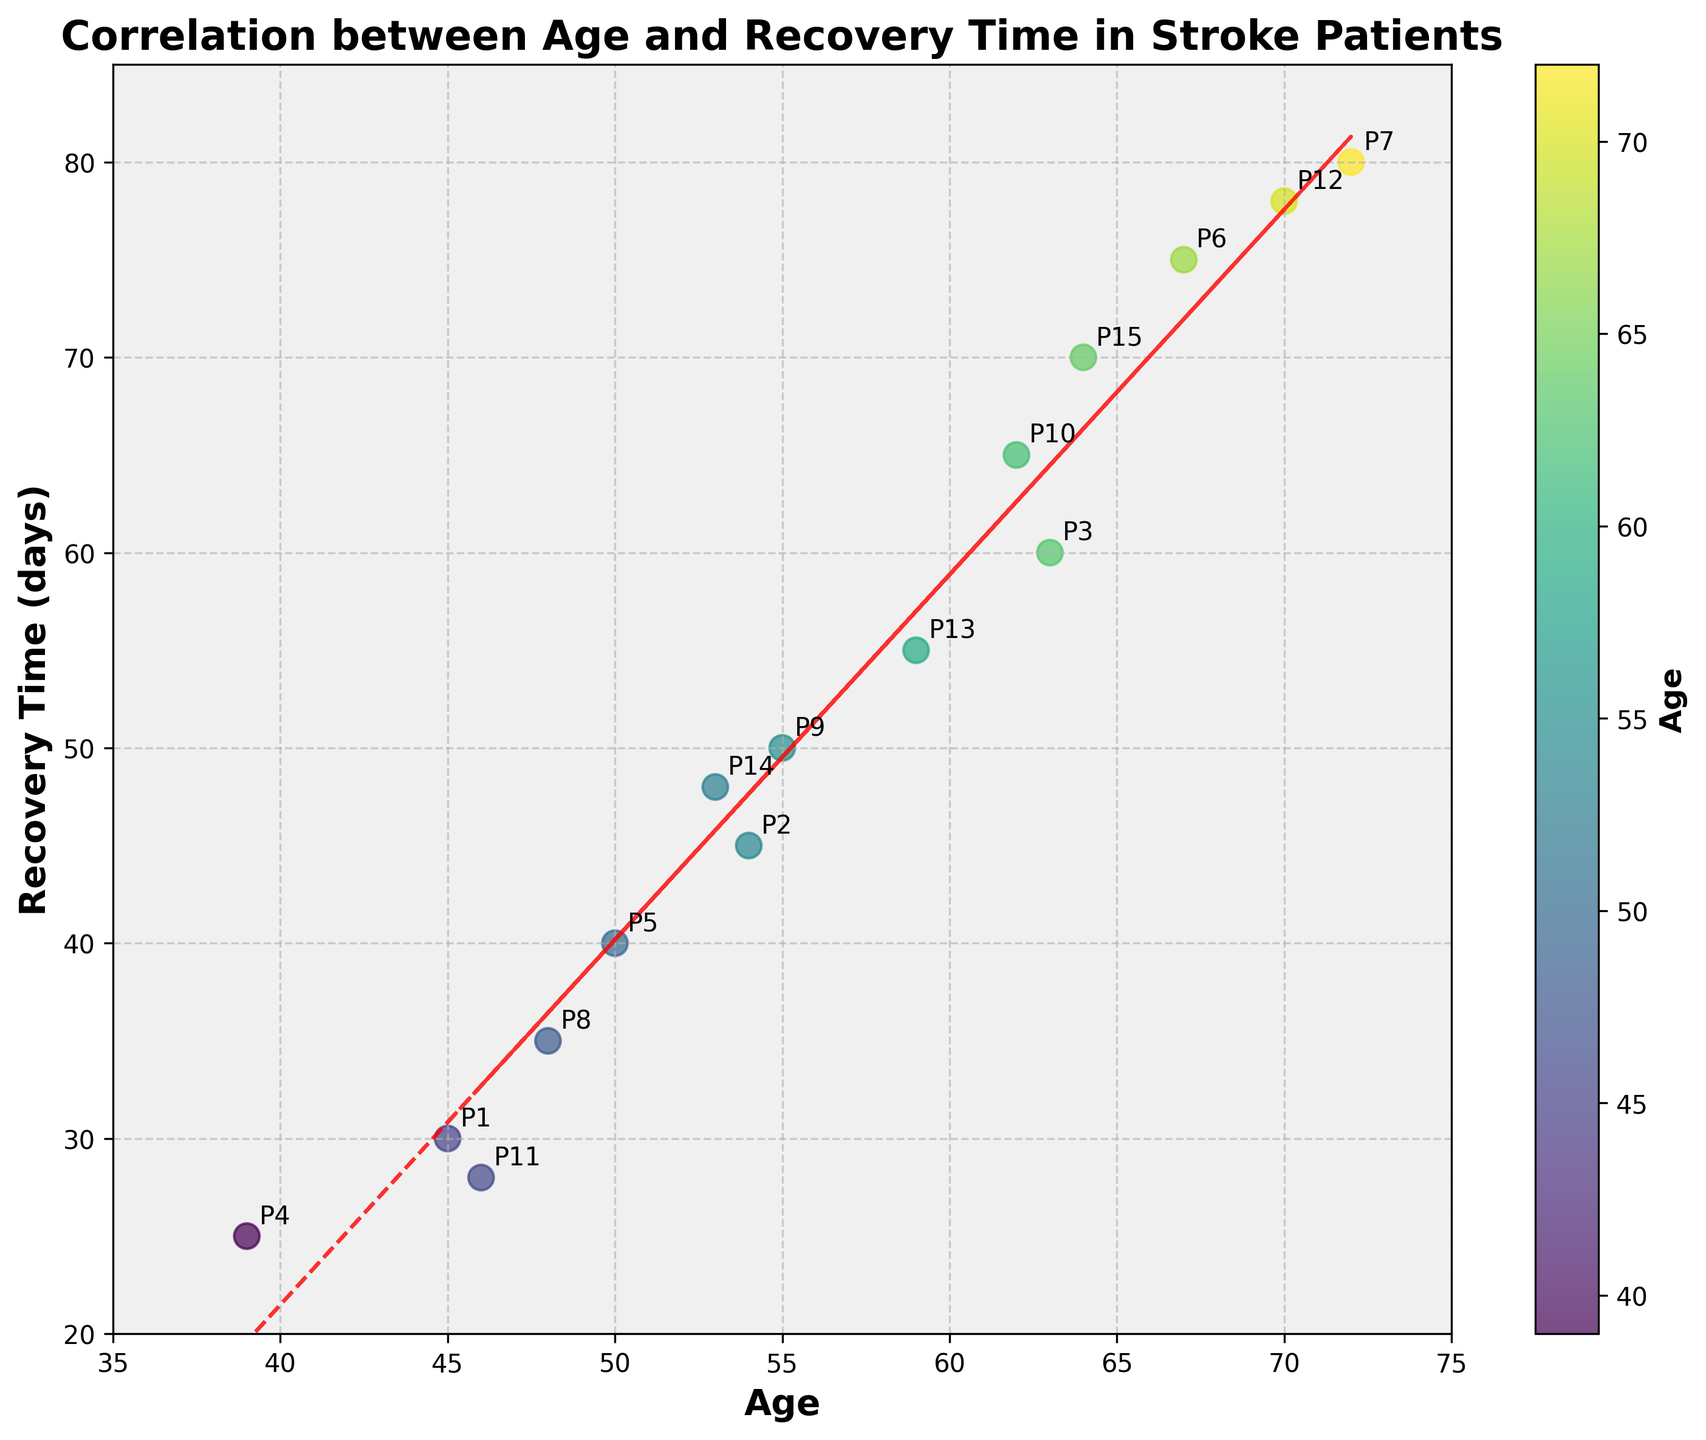What does the title of the figure indicate? The title indicates the relationship being examined in the scatter plot, specifically the correlation between the age of stroke patients and their recovery time in days.
Answer: Correlation between Age and Recovery Time in Stroke Patients What are the labels on the x and y axes? The x-axis is labeled "Age" and the y-axis is labeled "Recovery Time (days)". These labels indicate what each axis represents in the plot.
Answer: Age; Recovery Time (days) How many data points are plotted in the scatter plot? There are 15 points plotted, corresponding to the 15 patients listed in the data. By counting the number of annotations labeled "P1" through "P15", one can confirm the total number of data points.
Answer: 15 Which age group has the highest recovery time? By observing the scatter plot, the highest recovery time is 80 days, and the corresponding age of the patients is 72, which is annotated as "P7".
Answer: 72 What is the general trend observed in the scatter plot regarding the relationship between age and recovery time? The scatter plot and the red dashed line (trend line) suggest a positive correlation, meaning that as age increases, the recovery time tends to increase as well.
Answer: Positive correlation Which patient had the quickest recovery time, and what was their age? The quickest recovery time is 25 days, indicated by "P4". The corresponding age of this patient is 39.
Answer: P4, 39 Is there any patient aged above 65 who had a recovery time less than 70 days? By inspecting the scatter plot, there is one patient (P6) aged 67 who had a recovery time of 75 days, which is above 70 days. Another patient (P12) aged 70 had a recovery time of 78 days. Thus, there is no patient aged above 65 who had a recovery time less than 70 days.
Answer: No What is the mean recovery time of patients aged 50 or above based on the plot? To find this, identify the patients aged 50 or above: P2 (45 days), P5 (40 days), P6 (75 days), P7 (80 days), P9 (50 days), P10 (65 days), P12 (78 days), P13 (55 days), P14 (48 days), P15 (70 days). Sum up their recovery times (45 + 40 + 75 + 80 + 50 + 65 + 78 + 55 + 48 + 70 = 606) and divide by the count (10).
Answer: 60.6 days Which patient aged below 50 had the shortest recovery time, and how long was it? Inspecting patients aged below 50, we observe their recovery times: P1 (30 days), P4 (25 days), P8 (35 days), P11 (28 days). The shortest is 25 days by P4.
Answer: P4, 25 days Does the color gradient and color bar provide any additional information? Yes, the color gradient and color bar on the right side of the plot represent the ages of the patients. Different shades indicate different ages, enhancing the visual understanding of the age distribution.
Answer: Yes 